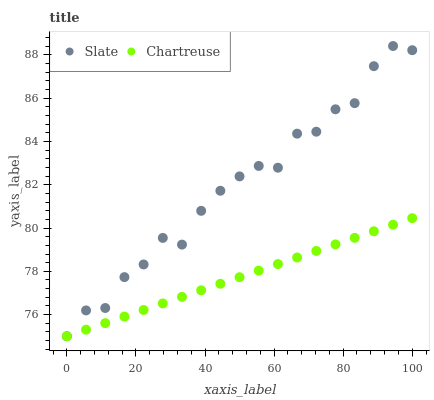Does Chartreuse have the minimum area under the curve?
Answer yes or no. Yes. Does Slate have the maximum area under the curve?
Answer yes or no. Yes. Does Chartreuse have the maximum area under the curve?
Answer yes or no. No. Is Chartreuse the smoothest?
Answer yes or no. Yes. Is Slate the roughest?
Answer yes or no. Yes. Is Chartreuse the roughest?
Answer yes or no. No. Does Slate have the lowest value?
Answer yes or no. Yes. Does Slate have the highest value?
Answer yes or no. Yes. Does Chartreuse have the highest value?
Answer yes or no. No. Does Chartreuse intersect Slate?
Answer yes or no. Yes. Is Chartreuse less than Slate?
Answer yes or no. No. Is Chartreuse greater than Slate?
Answer yes or no. No. 